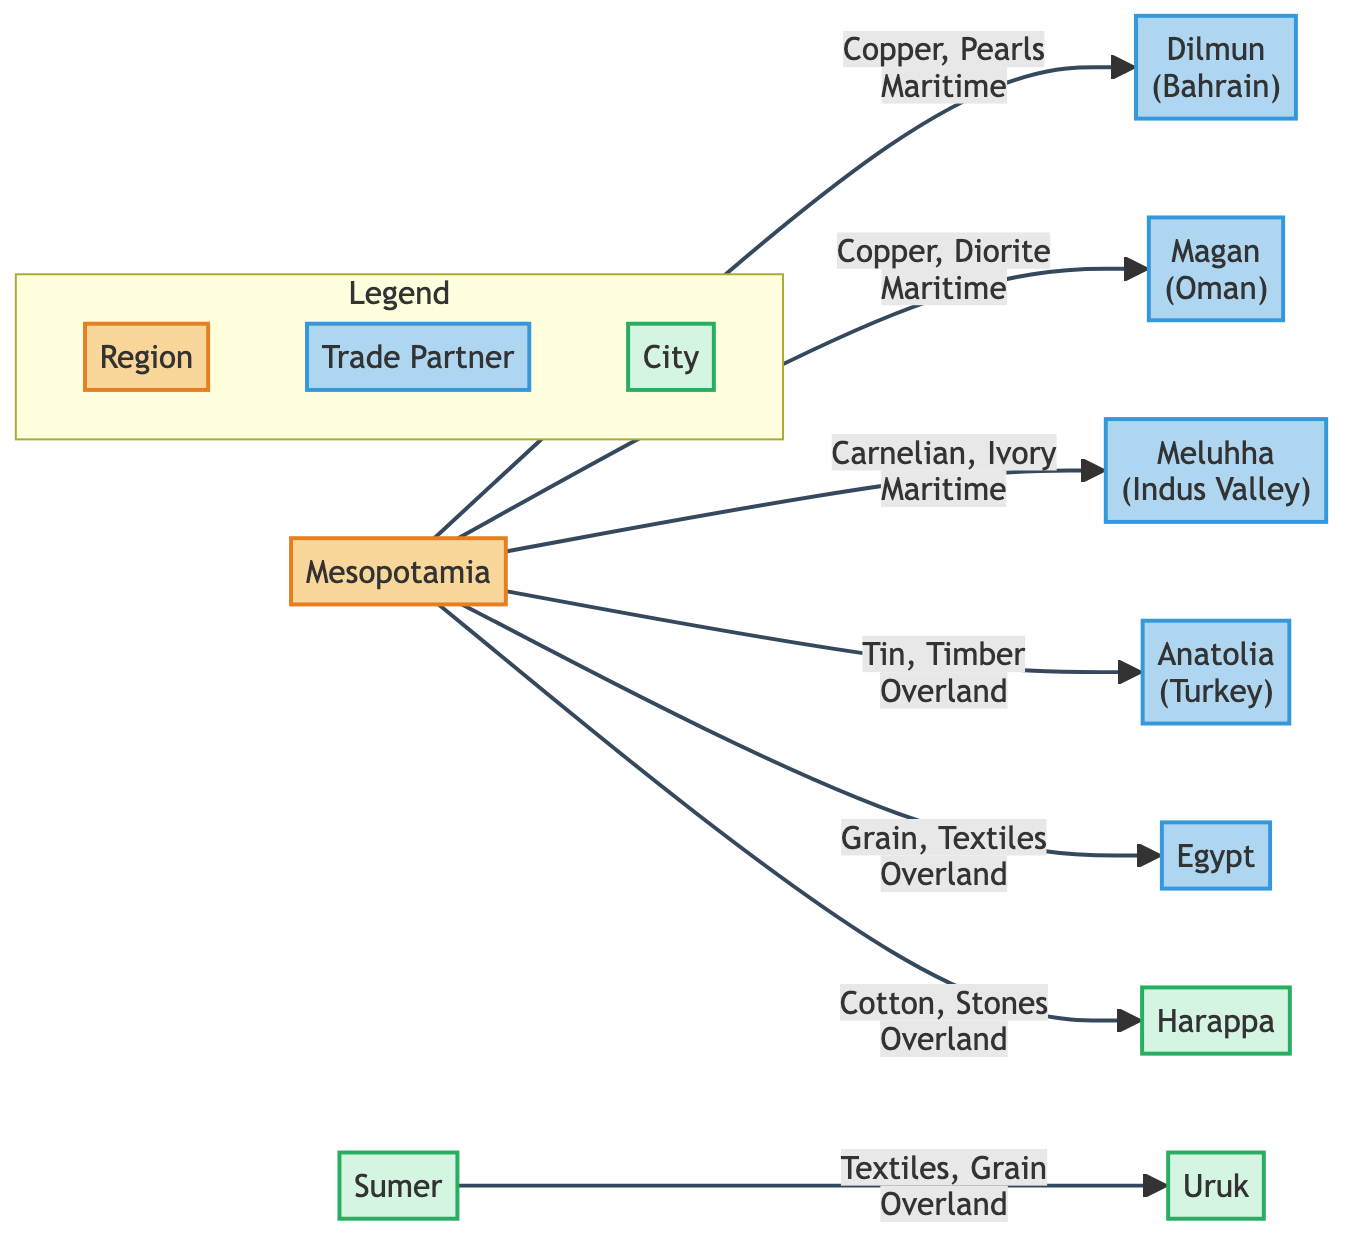What goods were exchanged between Mesopotamia and Dilmun? The diagram shows that Mesopotamia exchanged Copper and Pearls with Dilmun via maritime routes. This information is found by tracing the arrow from Mesopotamia to Dilmun and noting the goods listed.
Answer: Copper, Pearls How many trade partners does Mesopotamia have? By counting the arrows leading from Mesopotamia to other nodes, we can identify that there are five distinct trade partners listed: Dilmun, Magan, Meluhha, Anatolia, and Egypt.
Answer: 5 What is the primary good exchanged with Harappa? The flow from Mesopotamia to Harappa indicates the exchange of Cotton and Stones. The primary good can be interpreted as any of the goods listed. Here, either can be considered primary, but given the context of significant trade, Cotton may be seen as more notable.
Answer: Cotton, Stones Which region was connected to Mesopotamia via overland routes? The arrows towards Anatolia and Egypt indicate that both are connected to Mesopotamia through overland routes, as stated in the diagram. Hence, the answer identifies two regions.
Answer: Anatolia, Egypt What city exchanges textiles and grain with Uruk? The diagram shows an arrow from Sumer to Uruk, indicating that Sumer exchanges Textiles and Grain with Uruk. This can be corroborated by noting the direction of the flow between the two cities.
Answer: Sumer What type of goods does Mesopotamia trade with Meluhha? The diagram specifies that Mesopotamia trades Carnelian and Ivory with Meluhha, which are listed adjacent to the arrow pointing towards Meluhha.
Answer: Carnelian, Ivory How many total cities are depicted in the diagram? By counting the distinct city nodes in the diagram, we find Harappa, Sumer, and Uruk, which totals three cities.
Answer: 3 What type of trade did Mesopotamia engage in with Magan? The diagram indicates that Mesopotamia engaged in maritime trade with Magan, exchanging Copper and Diorite. The type of trade can be identified by the path marking.
Answer: Maritime 